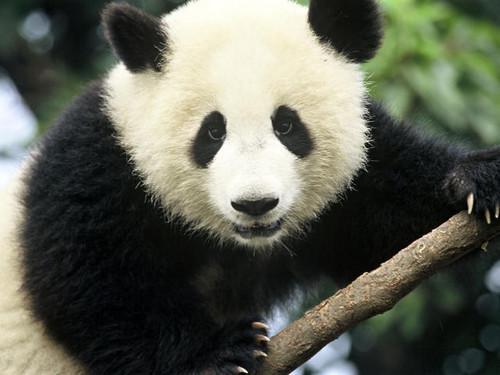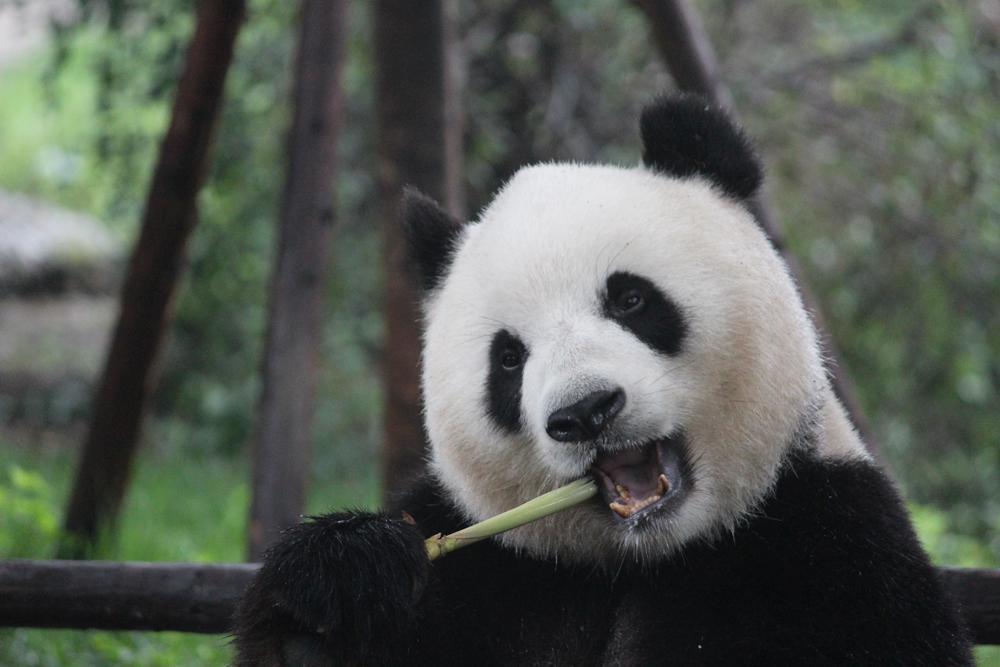The first image is the image on the left, the second image is the image on the right. For the images displayed, is the sentence "Two pandas are embracing each other." factually correct? Answer yes or no. No. The first image is the image on the left, the second image is the image on the right. Examine the images to the left and right. Is the description "An image shows a panda chewing on a green stalk." accurate? Answer yes or no. Yes. 